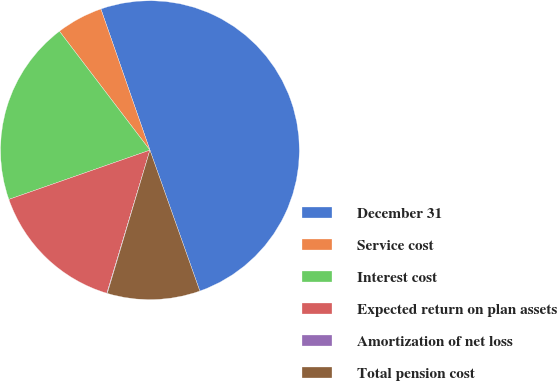Convert chart. <chart><loc_0><loc_0><loc_500><loc_500><pie_chart><fcel>December 31<fcel>Service cost<fcel>Interest cost<fcel>Expected return on plan assets<fcel>Amortization of net loss<fcel>Total pension cost<nl><fcel>49.9%<fcel>5.03%<fcel>19.99%<fcel>15.0%<fcel>0.05%<fcel>10.02%<nl></chart> 